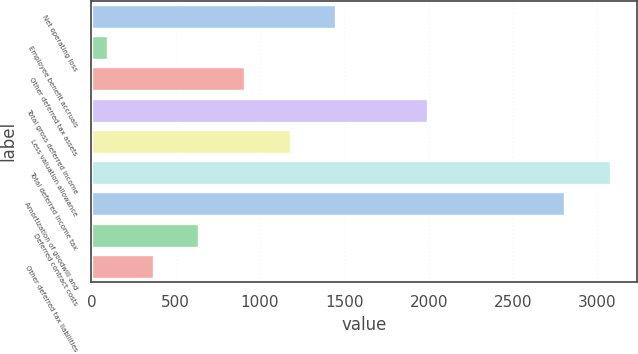Convert chart to OTSL. <chart><loc_0><loc_0><loc_500><loc_500><bar_chart><fcel>Net operating loss<fcel>Employee benefit accruals<fcel>Other deferred tax assets<fcel>Total gross deferred income<fcel>Less valuation allowance<fcel>Total deferred income tax<fcel>Amortization of goodwill and<fcel>Deferred contract costs<fcel>Other deferred tax liabilities<nl><fcel>1453.5<fcel>98<fcel>911.3<fcel>1995.7<fcel>1182.4<fcel>3080.2<fcel>2809.1<fcel>640.2<fcel>369.1<nl></chart> 